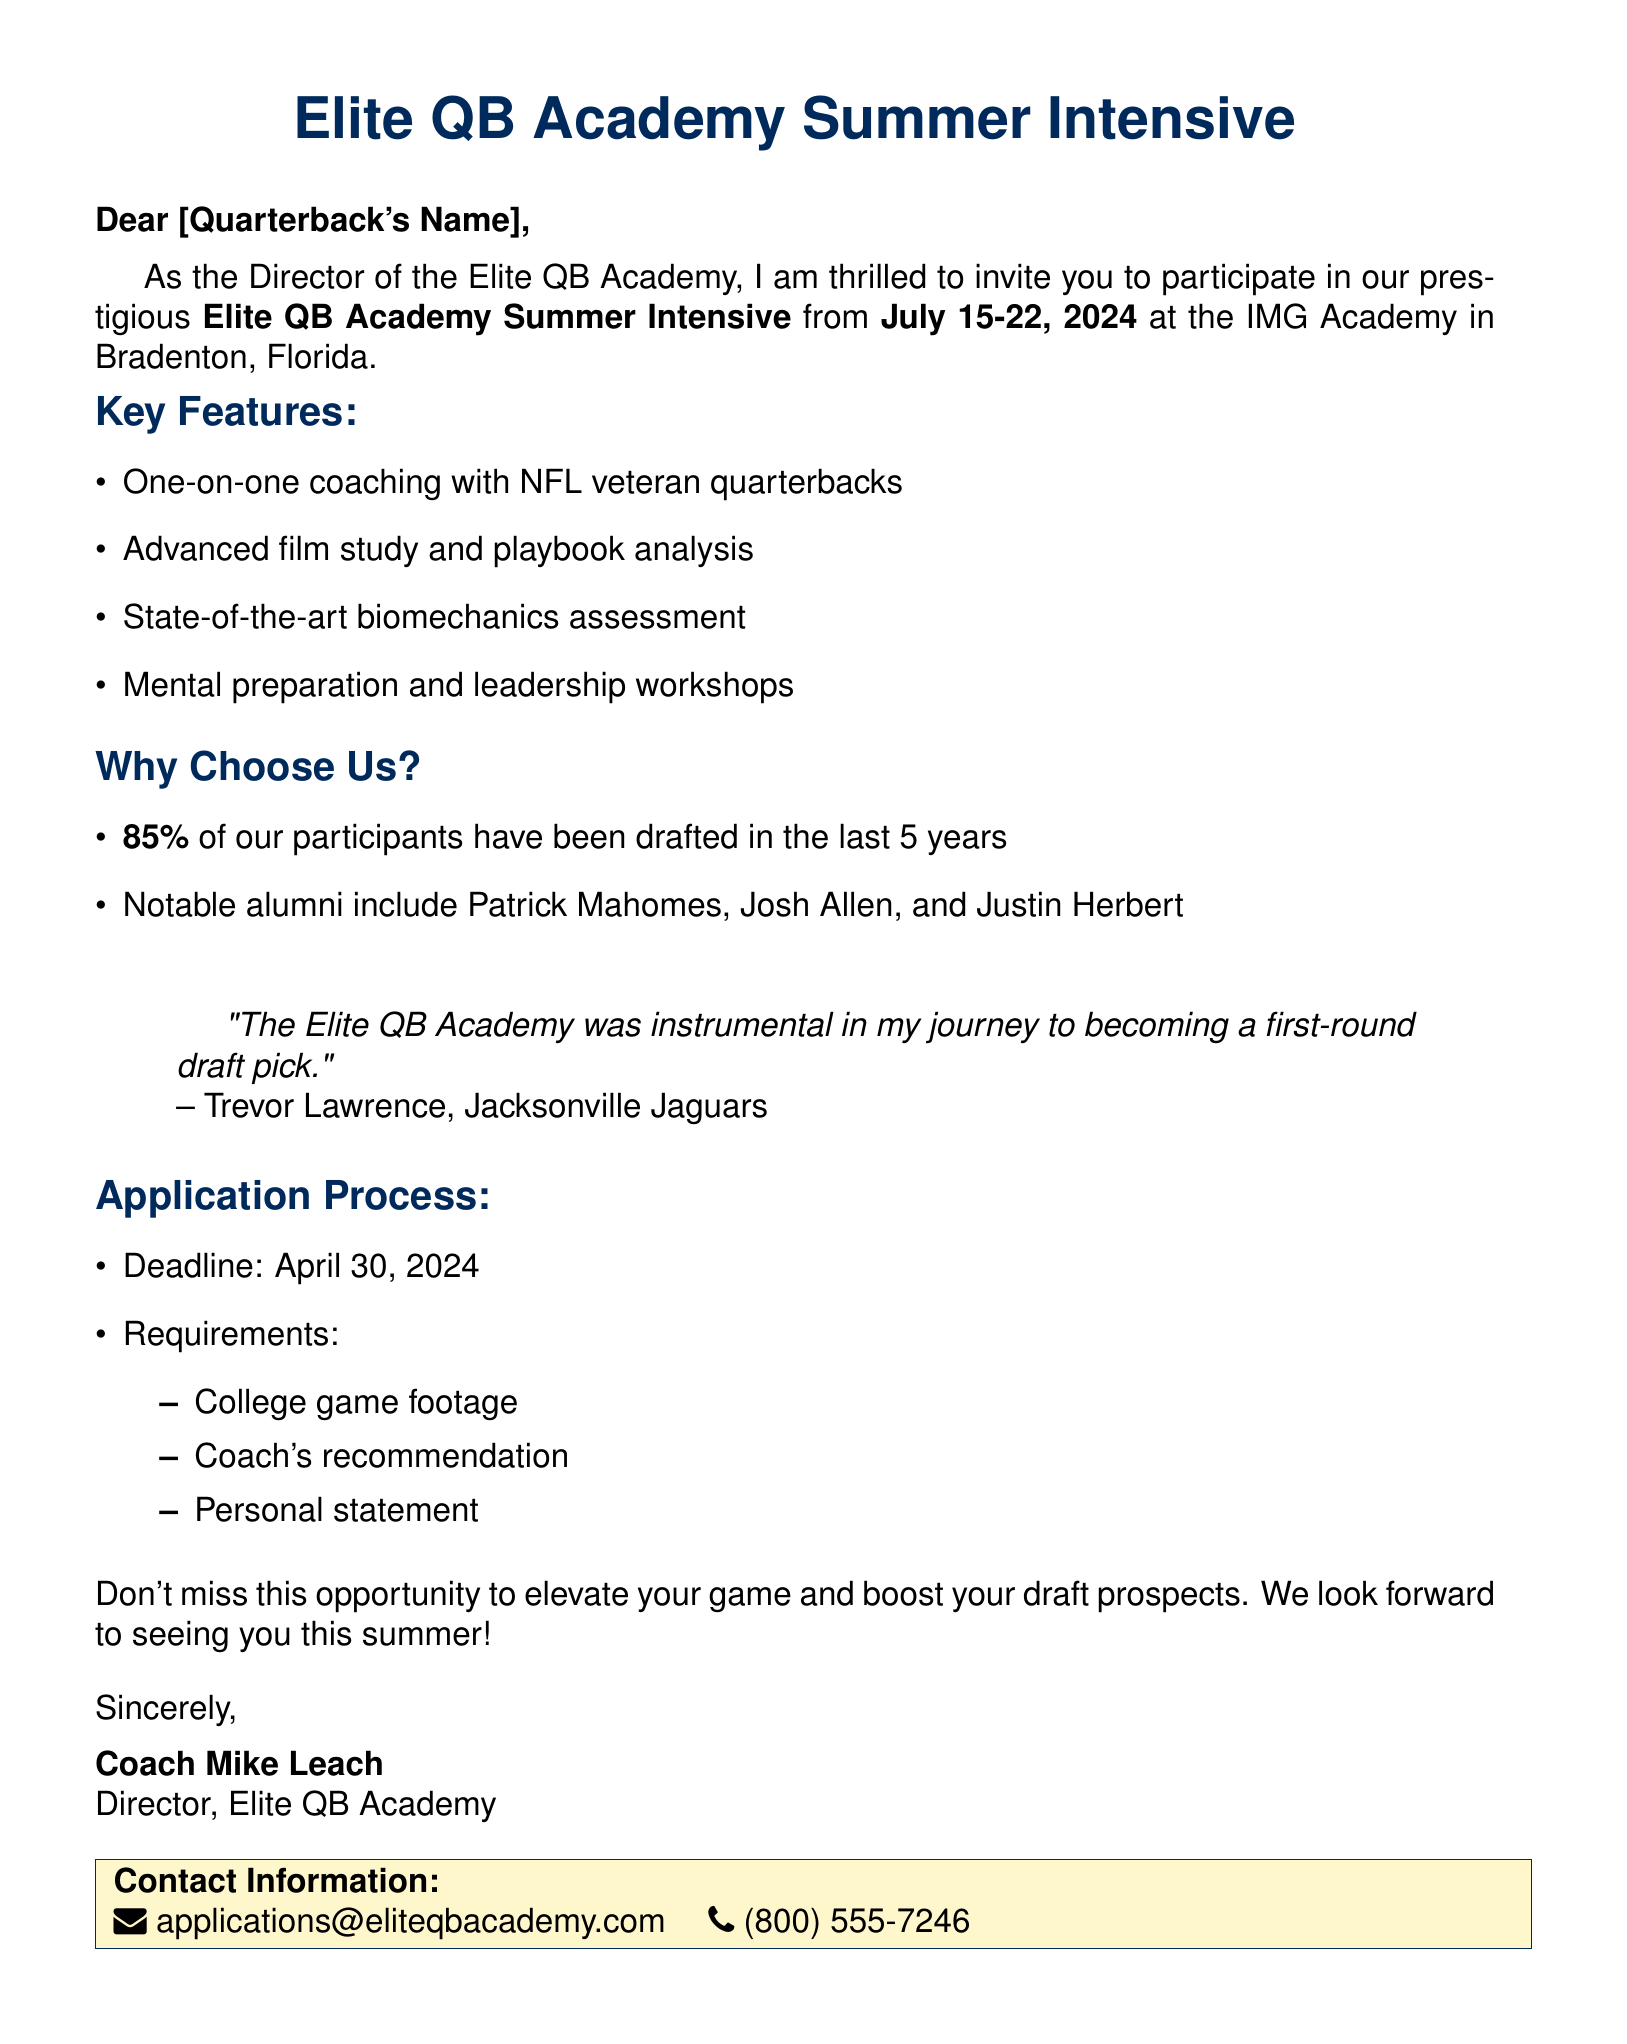What is the name of the training camp? The name of the training camp is highlighted in the document as the Elite QB Academy Summer Intensive.
Answer: Elite QB Academy Summer Intensive What are the camp dates? The camp dates are specified in the document as July 15-22, 2024.
Answer: July 15-22, 2024 Where is the camp located? The document states that the camp is located at IMG Academy, Bradenton, Florida.
Answer: IMG Academy, Bradenton, Florida What is the application deadline? The application deadline is found in the document as April 30, 2024.
Answer: April 30, 2024 What percentage of participants were drafted in the last 5 years? The document mentions that 85% of participants have been drafted in the last 5 years.
Answer: 85% Who is a notable alumnus of the camp? The document lists several notable alumni; one example is Patrick Mahomes.
Answer: Patrick Mahomes What is one key feature of the camp? The document lists multiple features, including one-on-one coaching with NFL veteran quarterbacks.
Answer: One-on-one coaching with NFL veteran quarterbacks Who should the personal statement be addressed to? The context of the personal statement is implied to be directed to the camp's admission process, as it is required for application.
Answer: Elite QB Academy What is a testimonial about the camp? The document includes a testimonial quote from Trevor Lawrence mentioning its significance in his journey to the draft.
Answer: "The Elite QB Academy was instrumental in my journey to becoming a first-round draft pick." 